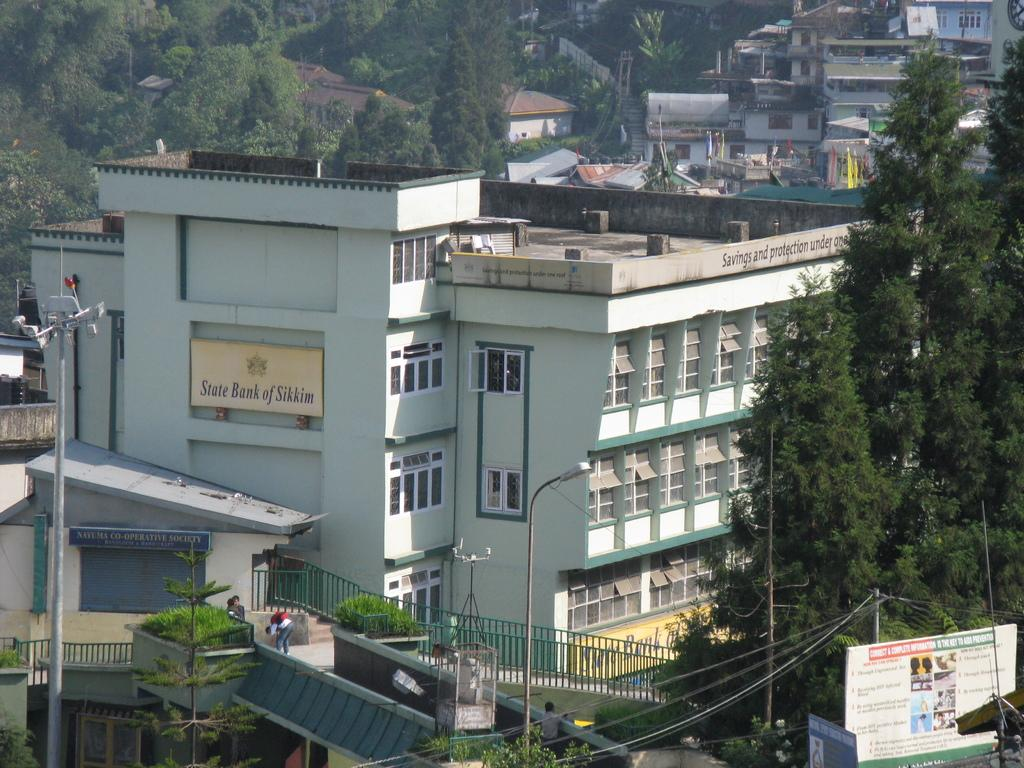What is the perspective of the image? The image shows a top view of a city. What types of structures can be seen in the image? There are many buildings, houses, and poles visible in the image. Are there any natural elements present in the image? Yes, trees are visible in the image. What type of meat is being served at the restaurant in the image? There is no restaurant or meat present in the image; it shows a top view of a city with various structures and elements. What is the condition of the teeth of the person in the image? There is no person present in the image, so their teeth cannot be observed. 